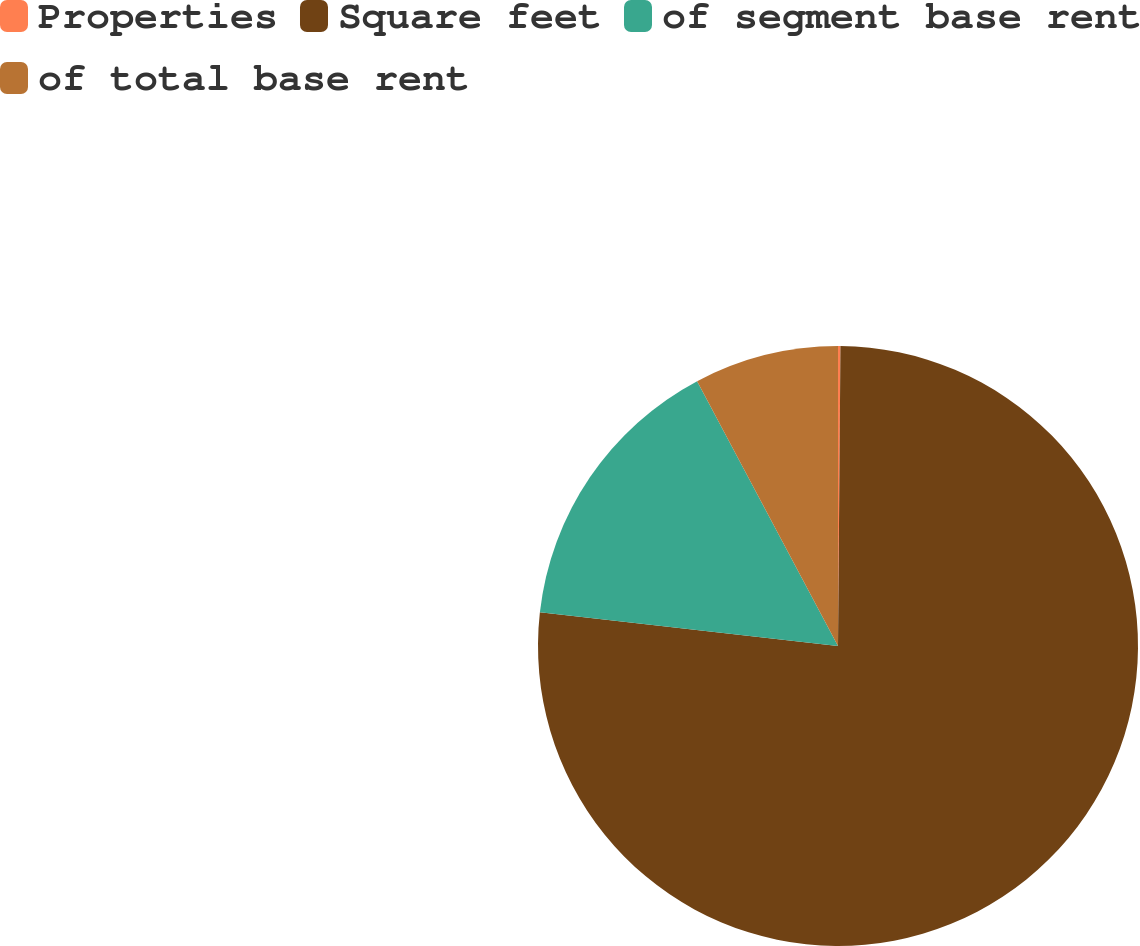<chart> <loc_0><loc_0><loc_500><loc_500><pie_chart><fcel>Properties<fcel>Square feet<fcel>of segment base rent<fcel>of total base rent<nl><fcel>0.13%<fcel>76.66%<fcel>15.43%<fcel>7.78%<nl></chart> 